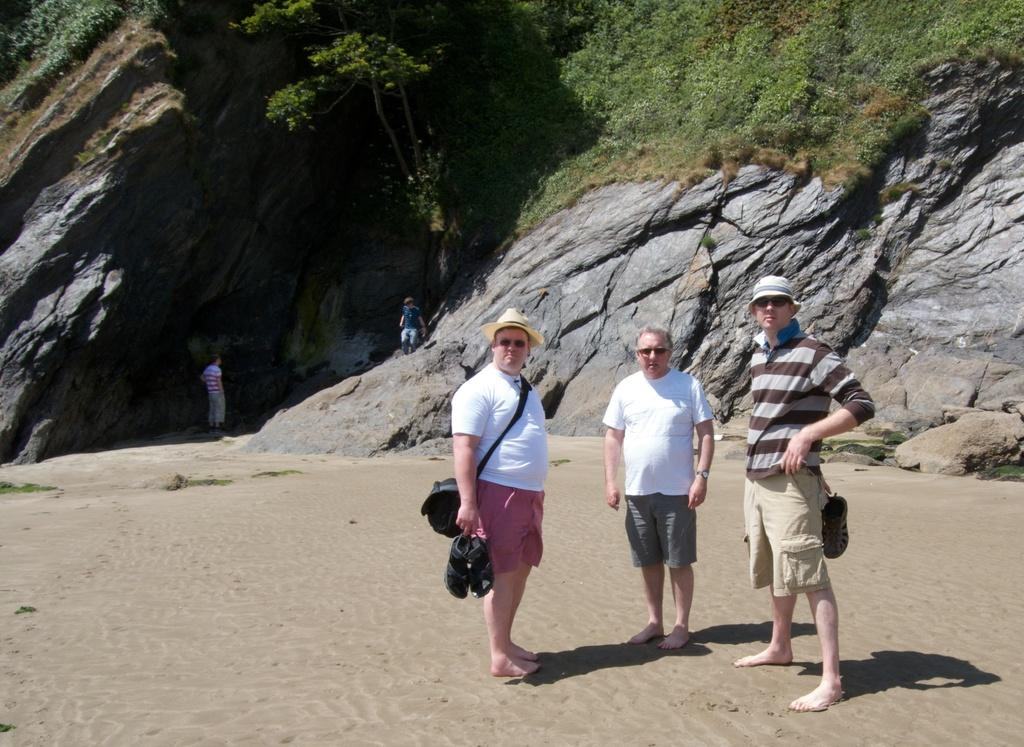How many people are in the image? There are people in the image, but the exact number is not specified. What are some people doing in the image? Some people are carrying bags, and some are wearing hats. What type of natural environment is visible in the image? There is grass and plants visible in the image. What other objects can be seen in the image? There are other objects present in the image, but their specific nature is not mentioned. What type of pipe can be seen in the image? There is no pipe present in the image. What shape is the square object in the image? There is no square object present in the image. 